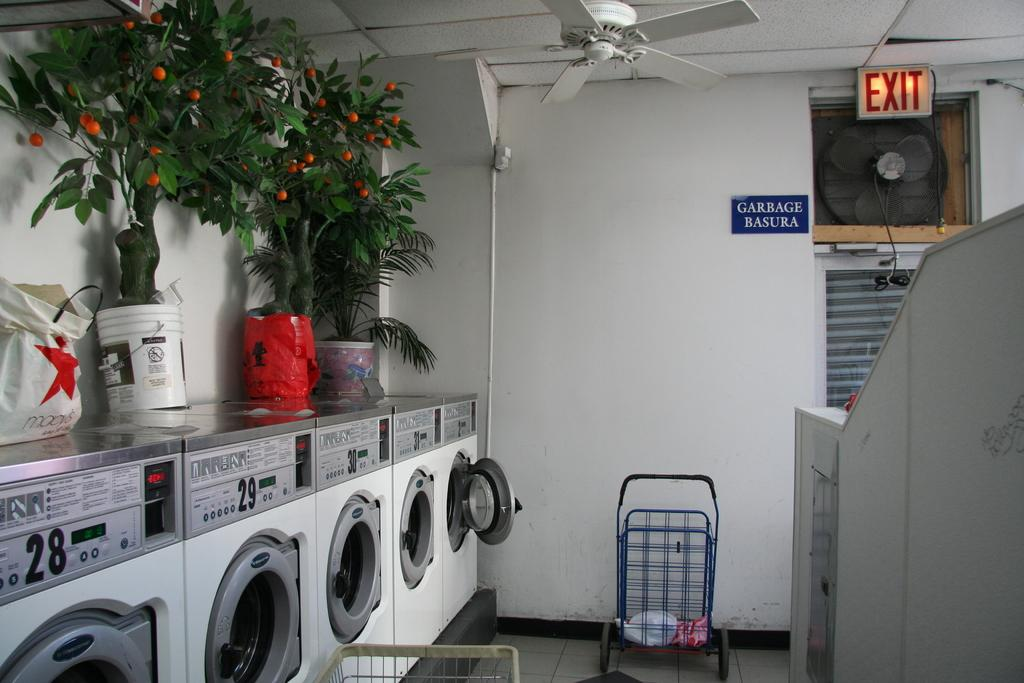<image>
Create a compact narrative representing the image presented. A view of the exit to the of a wall of dryers in a public laundromat. 